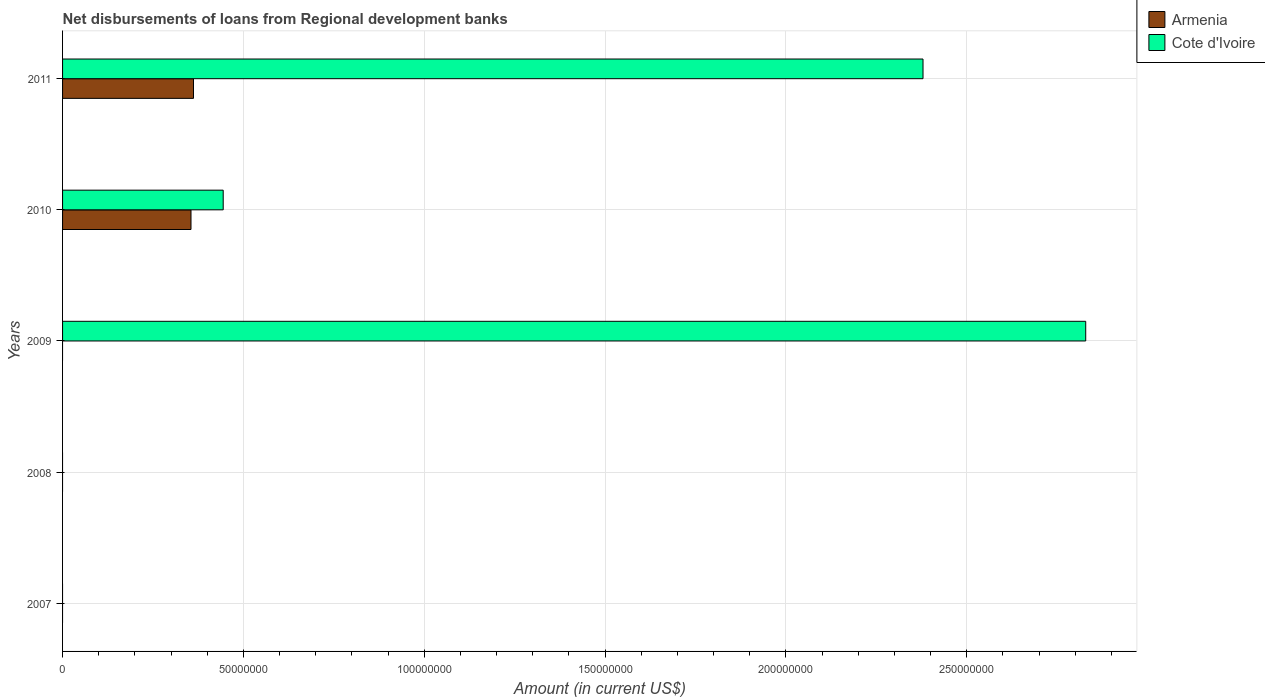How many bars are there on the 3rd tick from the top?
Offer a terse response. 1. How many bars are there on the 5th tick from the bottom?
Ensure brevity in your answer.  2. What is the label of the 3rd group of bars from the top?
Your answer should be very brief. 2009. What is the amount of disbursements of loans from regional development banks in Armenia in 2011?
Keep it short and to the point. 3.62e+07. Across all years, what is the maximum amount of disbursements of loans from regional development banks in Armenia?
Ensure brevity in your answer.  3.62e+07. Across all years, what is the minimum amount of disbursements of loans from regional development banks in Armenia?
Your answer should be compact. 0. What is the total amount of disbursements of loans from regional development banks in Cote d'Ivoire in the graph?
Offer a very short reply. 5.65e+08. What is the difference between the amount of disbursements of loans from regional development banks in Cote d'Ivoire in 2010 and that in 2011?
Make the answer very short. -1.94e+08. What is the difference between the amount of disbursements of loans from regional development banks in Cote d'Ivoire in 2010 and the amount of disbursements of loans from regional development banks in Armenia in 2011?
Give a very brief answer. 8.22e+06. What is the average amount of disbursements of loans from regional development banks in Cote d'Ivoire per year?
Ensure brevity in your answer.  1.13e+08. In the year 2011, what is the difference between the amount of disbursements of loans from regional development banks in Cote d'Ivoire and amount of disbursements of loans from regional development banks in Armenia?
Keep it short and to the point. 2.02e+08. What is the ratio of the amount of disbursements of loans from regional development banks in Armenia in 2010 to that in 2011?
Your answer should be very brief. 0.98. Is the amount of disbursements of loans from regional development banks in Armenia in 2010 less than that in 2011?
Provide a succinct answer. Yes. What is the difference between the highest and the second highest amount of disbursements of loans from regional development banks in Cote d'Ivoire?
Keep it short and to the point. 4.50e+07. What is the difference between the highest and the lowest amount of disbursements of loans from regional development banks in Cote d'Ivoire?
Give a very brief answer. 2.83e+08. In how many years, is the amount of disbursements of loans from regional development banks in Cote d'Ivoire greater than the average amount of disbursements of loans from regional development banks in Cote d'Ivoire taken over all years?
Offer a very short reply. 2. How many bars are there?
Ensure brevity in your answer.  5. How many years are there in the graph?
Keep it short and to the point. 5. What is the difference between two consecutive major ticks on the X-axis?
Your answer should be very brief. 5.00e+07. Does the graph contain any zero values?
Make the answer very short. Yes. Does the graph contain grids?
Keep it short and to the point. Yes. Where does the legend appear in the graph?
Your answer should be compact. Top right. How many legend labels are there?
Provide a succinct answer. 2. How are the legend labels stacked?
Make the answer very short. Vertical. What is the title of the graph?
Make the answer very short. Net disbursements of loans from Regional development banks. Does "Trinidad and Tobago" appear as one of the legend labels in the graph?
Your answer should be compact. No. What is the label or title of the X-axis?
Your response must be concise. Amount (in current US$). What is the label or title of the Y-axis?
Offer a terse response. Years. What is the Amount (in current US$) of Cote d'Ivoire in 2007?
Your answer should be compact. 0. What is the Amount (in current US$) of Armenia in 2008?
Offer a very short reply. 0. What is the Amount (in current US$) of Cote d'Ivoire in 2009?
Your response must be concise. 2.83e+08. What is the Amount (in current US$) of Armenia in 2010?
Give a very brief answer. 3.55e+07. What is the Amount (in current US$) in Cote d'Ivoire in 2010?
Ensure brevity in your answer.  4.44e+07. What is the Amount (in current US$) in Armenia in 2011?
Keep it short and to the point. 3.62e+07. What is the Amount (in current US$) in Cote d'Ivoire in 2011?
Offer a terse response. 2.38e+08. Across all years, what is the maximum Amount (in current US$) in Armenia?
Your answer should be very brief. 3.62e+07. Across all years, what is the maximum Amount (in current US$) of Cote d'Ivoire?
Provide a succinct answer. 2.83e+08. Across all years, what is the minimum Amount (in current US$) in Armenia?
Your response must be concise. 0. What is the total Amount (in current US$) of Armenia in the graph?
Give a very brief answer. 7.17e+07. What is the total Amount (in current US$) in Cote d'Ivoire in the graph?
Provide a short and direct response. 5.65e+08. What is the difference between the Amount (in current US$) of Cote d'Ivoire in 2009 and that in 2010?
Your answer should be compact. 2.38e+08. What is the difference between the Amount (in current US$) of Cote d'Ivoire in 2009 and that in 2011?
Your response must be concise. 4.50e+07. What is the difference between the Amount (in current US$) of Armenia in 2010 and that in 2011?
Give a very brief answer. -6.90e+05. What is the difference between the Amount (in current US$) in Cote d'Ivoire in 2010 and that in 2011?
Make the answer very short. -1.94e+08. What is the difference between the Amount (in current US$) of Armenia in 2010 and the Amount (in current US$) of Cote d'Ivoire in 2011?
Your response must be concise. -2.02e+08. What is the average Amount (in current US$) in Armenia per year?
Offer a very short reply. 1.43e+07. What is the average Amount (in current US$) of Cote d'Ivoire per year?
Ensure brevity in your answer.  1.13e+08. In the year 2010, what is the difference between the Amount (in current US$) of Armenia and Amount (in current US$) of Cote d'Ivoire?
Offer a very short reply. -8.90e+06. In the year 2011, what is the difference between the Amount (in current US$) of Armenia and Amount (in current US$) of Cote d'Ivoire?
Your answer should be very brief. -2.02e+08. What is the ratio of the Amount (in current US$) in Cote d'Ivoire in 2009 to that in 2010?
Provide a short and direct response. 6.37. What is the ratio of the Amount (in current US$) in Cote d'Ivoire in 2009 to that in 2011?
Your answer should be very brief. 1.19. What is the ratio of the Amount (in current US$) of Armenia in 2010 to that in 2011?
Your response must be concise. 0.98. What is the ratio of the Amount (in current US$) in Cote d'Ivoire in 2010 to that in 2011?
Offer a very short reply. 0.19. What is the difference between the highest and the second highest Amount (in current US$) of Cote d'Ivoire?
Provide a short and direct response. 4.50e+07. What is the difference between the highest and the lowest Amount (in current US$) of Armenia?
Make the answer very short. 3.62e+07. What is the difference between the highest and the lowest Amount (in current US$) of Cote d'Ivoire?
Ensure brevity in your answer.  2.83e+08. 